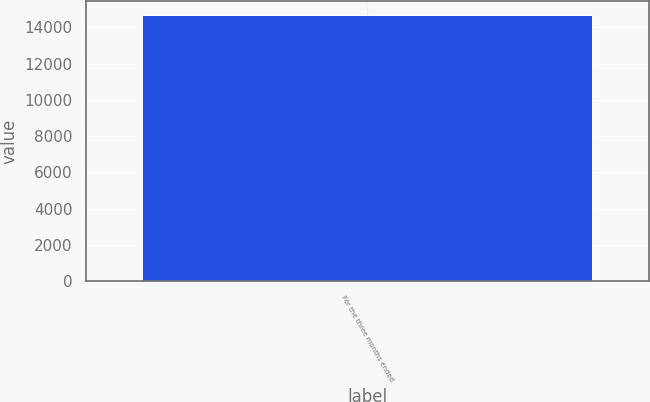<chart> <loc_0><loc_0><loc_500><loc_500><bar_chart><fcel>For the three months ended<nl><fcel>14686<nl></chart> 